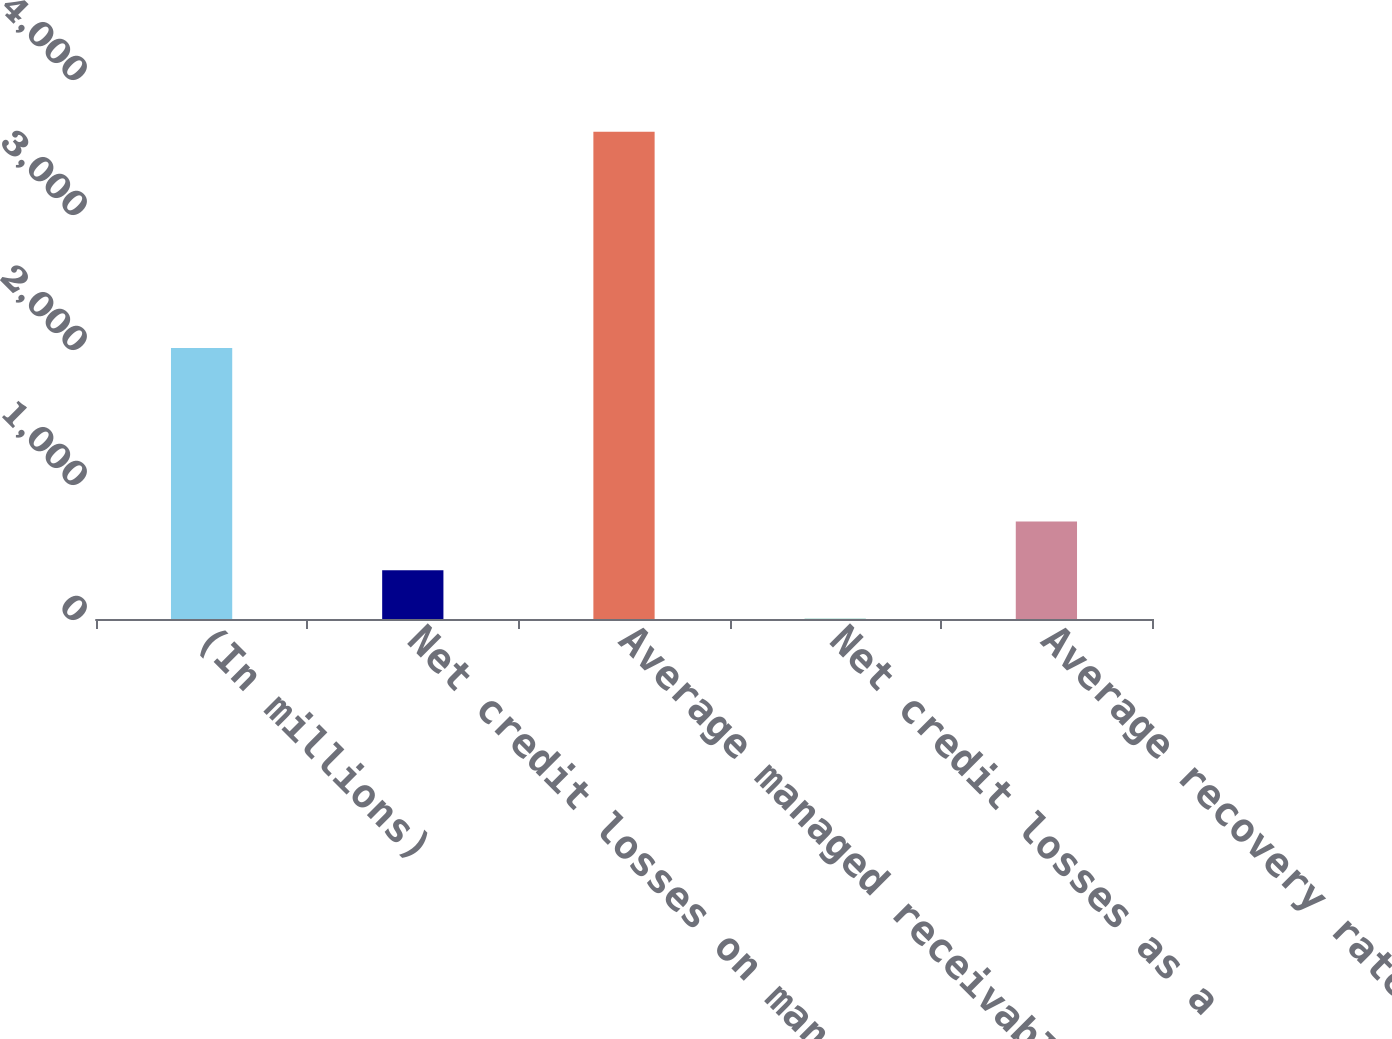Convert chart to OTSL. <chart><loc_0><loc_0><loc_500><loc_500><bar_chart><fcel>(In millions)<fcel>Net credit losses on managed<fcel>Average managed receivables<fcel>Net credit losses as a<fcel>Average recovery rate<nl><fcel>2008<fcel>361.79<fcel>3608.4<fcel>1.06<fcel>722.52<nl></chart> 